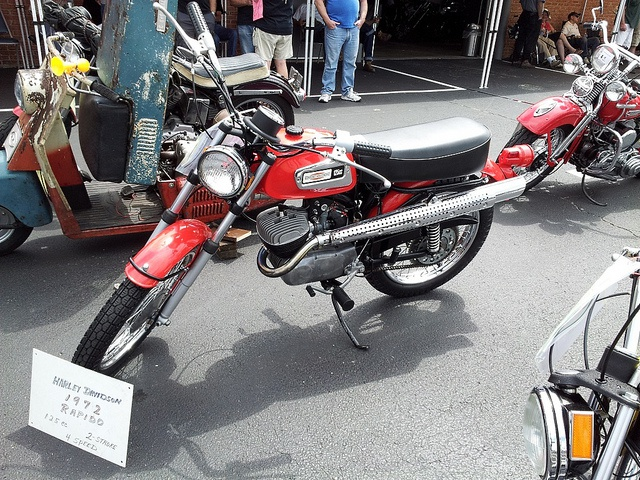Describe the objects in this image and their specific colors. I can see motorcycle in maroon, black, white, gray, and darkgray tones, motorcycle in maroon, black, gray, and darkgray tones, motorcycle in maroon, lightgray, black, darkgray, and gray tones, motorcycle in maroon, black, white, gray, and darkgray tones, and motorcycle in maroon, black, gray, darkgray, and lightgray tones in this image. 